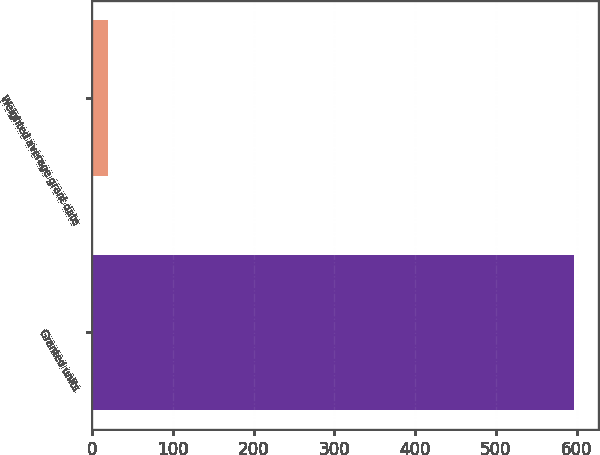Convert chart to OTSL. <chart><loc_0><loc_0><loc_500><loc_500><bar_chart><fcel>Granted units<fcel>Weighted average grant date<nl><fcel>597<fcel>18.88<nl></chart> 